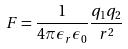Convert formula to latex. <formula><loc_0><loc_0><loc_500><loc_500>F = \frac { 1 } { 4 \pi \epsilon _ { r } \epsilon _ { 0 } } \frac { q _ { 1 } q _ { 2 } } { r ^ { 2 } }</formula> 